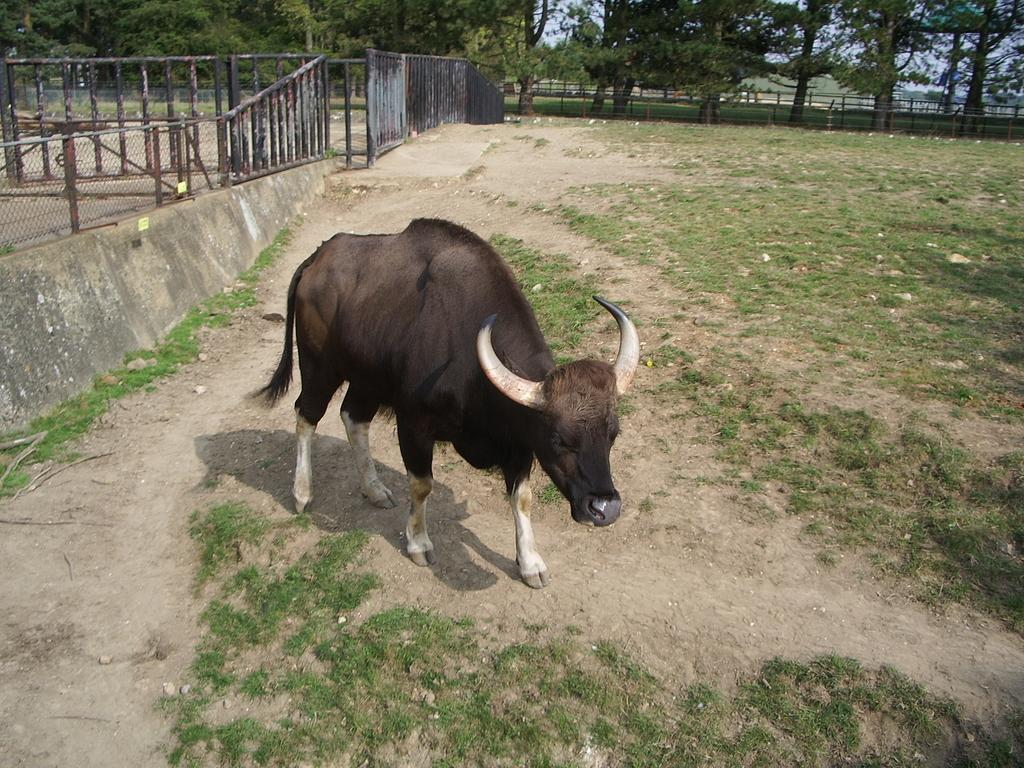What is the main subject in the center of the image? There is a bison in the center of the image. What can be seen in the top left side of the image? There is a boundary in the top left side of the image. What type of vegetation is visible at the top side of the image? There are trees at the top side of the image. What type of birthday celebration is taking place in the image? There is no indication of a birthday celebration in the image; it features a bison, a boundary, and trees. How does the feast look like in the image? There is no feast present in the image; it only shows a bison, a boundary, and trees. 